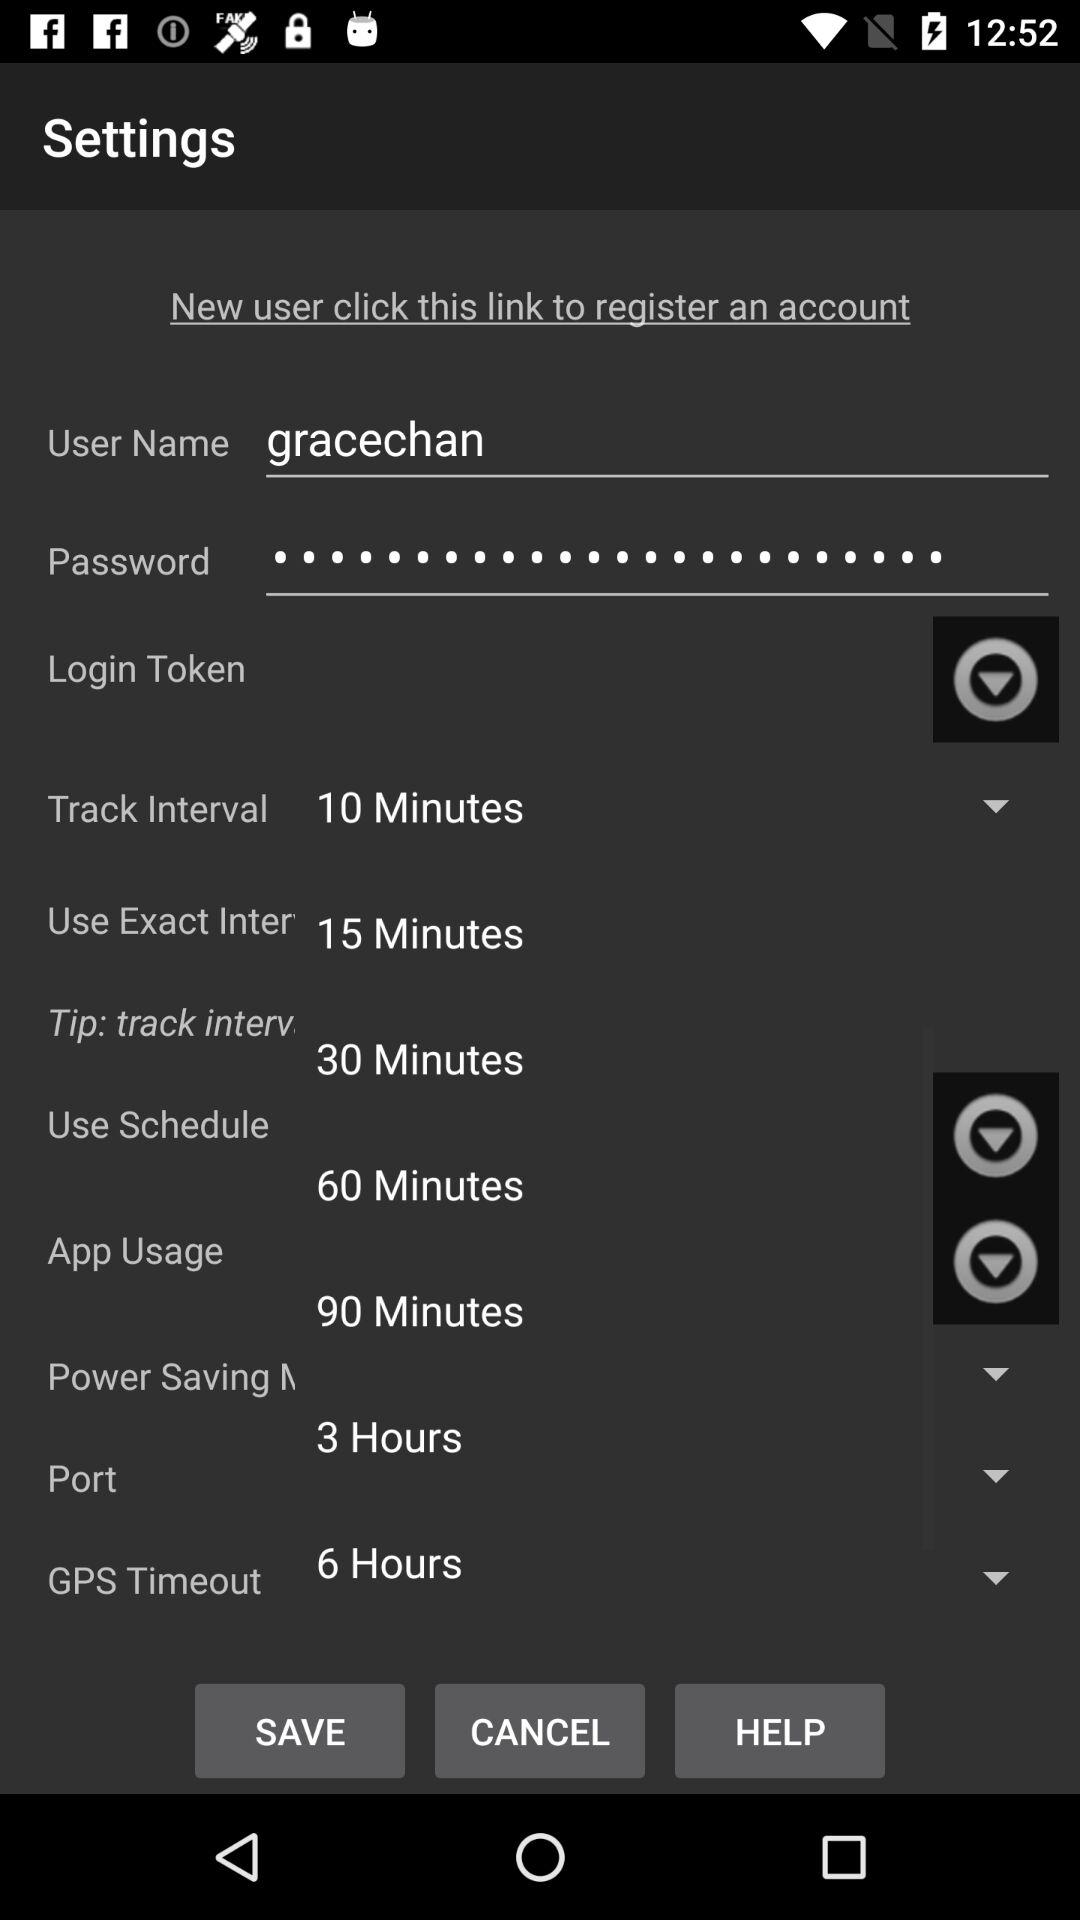What is the track interval?
When the provided information is insufficient, respond with <no answer>. <no answer> 